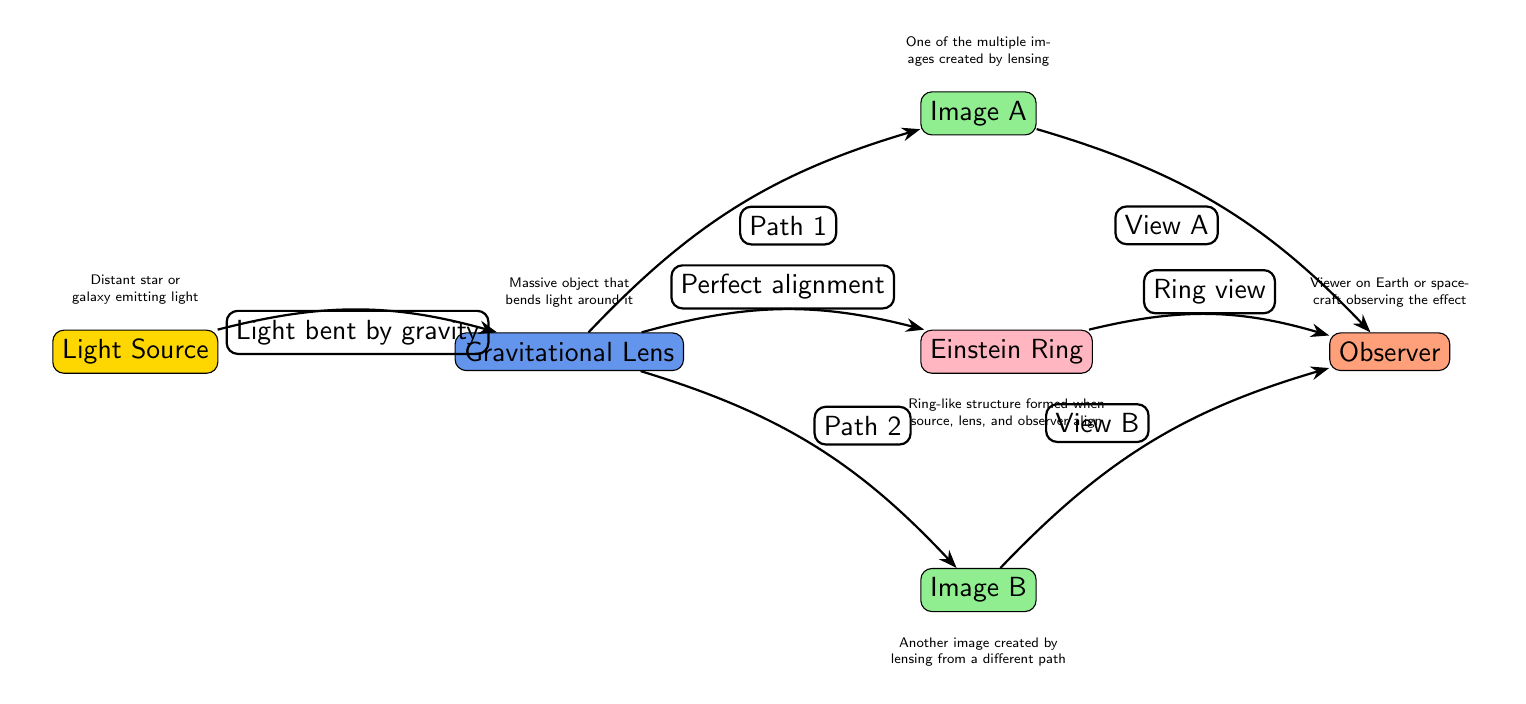What is the light source in the diagram? The light source is identified at the leftmost node, labeled "Light Source," representing a distant star or galaxy emitting light.
Answer: Light Source What two images are created by lensing? The diagram shows "Image A" and "Image B," which represent two different paths of light bent by the gravitational lens.
Answer: Image A and Image B What does the gravitational lens do? The node labeled "Gravitational Lens" indicates that it is a massive object that bends light around it, causing the phenomenon of gravitational lensing.
Answer: Bends light How many images can be observed from the gravitational lensing? From the diagram, two images are explicitly labeled (Image A and Image B), but there is also the potential for a ring view if aligned correctly. Thus, considering visibility, it can be seen as two primary images but suggests multiple images are possible.
Answer: Two What is the role of the observer in the diagram? The observer, labeled as "Observer," is positioned farthest right and refers to the viewer on Earth or a spacecraft observing the effect of gravitational lensing.
Answer: Observer What phenomenon occurs when the source, lens, and observer align? The alignment of the distant light source, the lens, and the observer leads to the formation of the "Einstein Ring," which is a specific visual effect of gravitational lensing evident in the diagram.
Answer: Einstein Ring Which two paths of light are labeled in the diagram? The diagram highlights "Path 1" leading to "Image A" and "Path 2" leading to "Image B," showcasing how light travels from the source through the lens to the observer.
Answer: Path 1 and Path 2 What color represents the gravitational lens? The gravitational lens node is filled with a color defined as light blue, determined by the RGB values assigned in the diagram.
Answer: Light blue What type of light phenomenon does the diagram illustrate? The overall diagram illustrates the concept of gravitational lensing, which visually demonstrates how gravity bends light around massive objects.
Answer: Gravitational lensing 